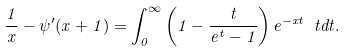Convert formula to latex. <formula><loc_0><loc_0><loc_500><loc_500>\frac { 1 } { x } - \psi ^ { \prime } ( x + 1 ) = \int _ { 0 } ^ { \infty } \left ( 1 - \frac { t } { e ^ { t } - 1 } \right ) e ^ { - x t } \ t d t .</formula> 